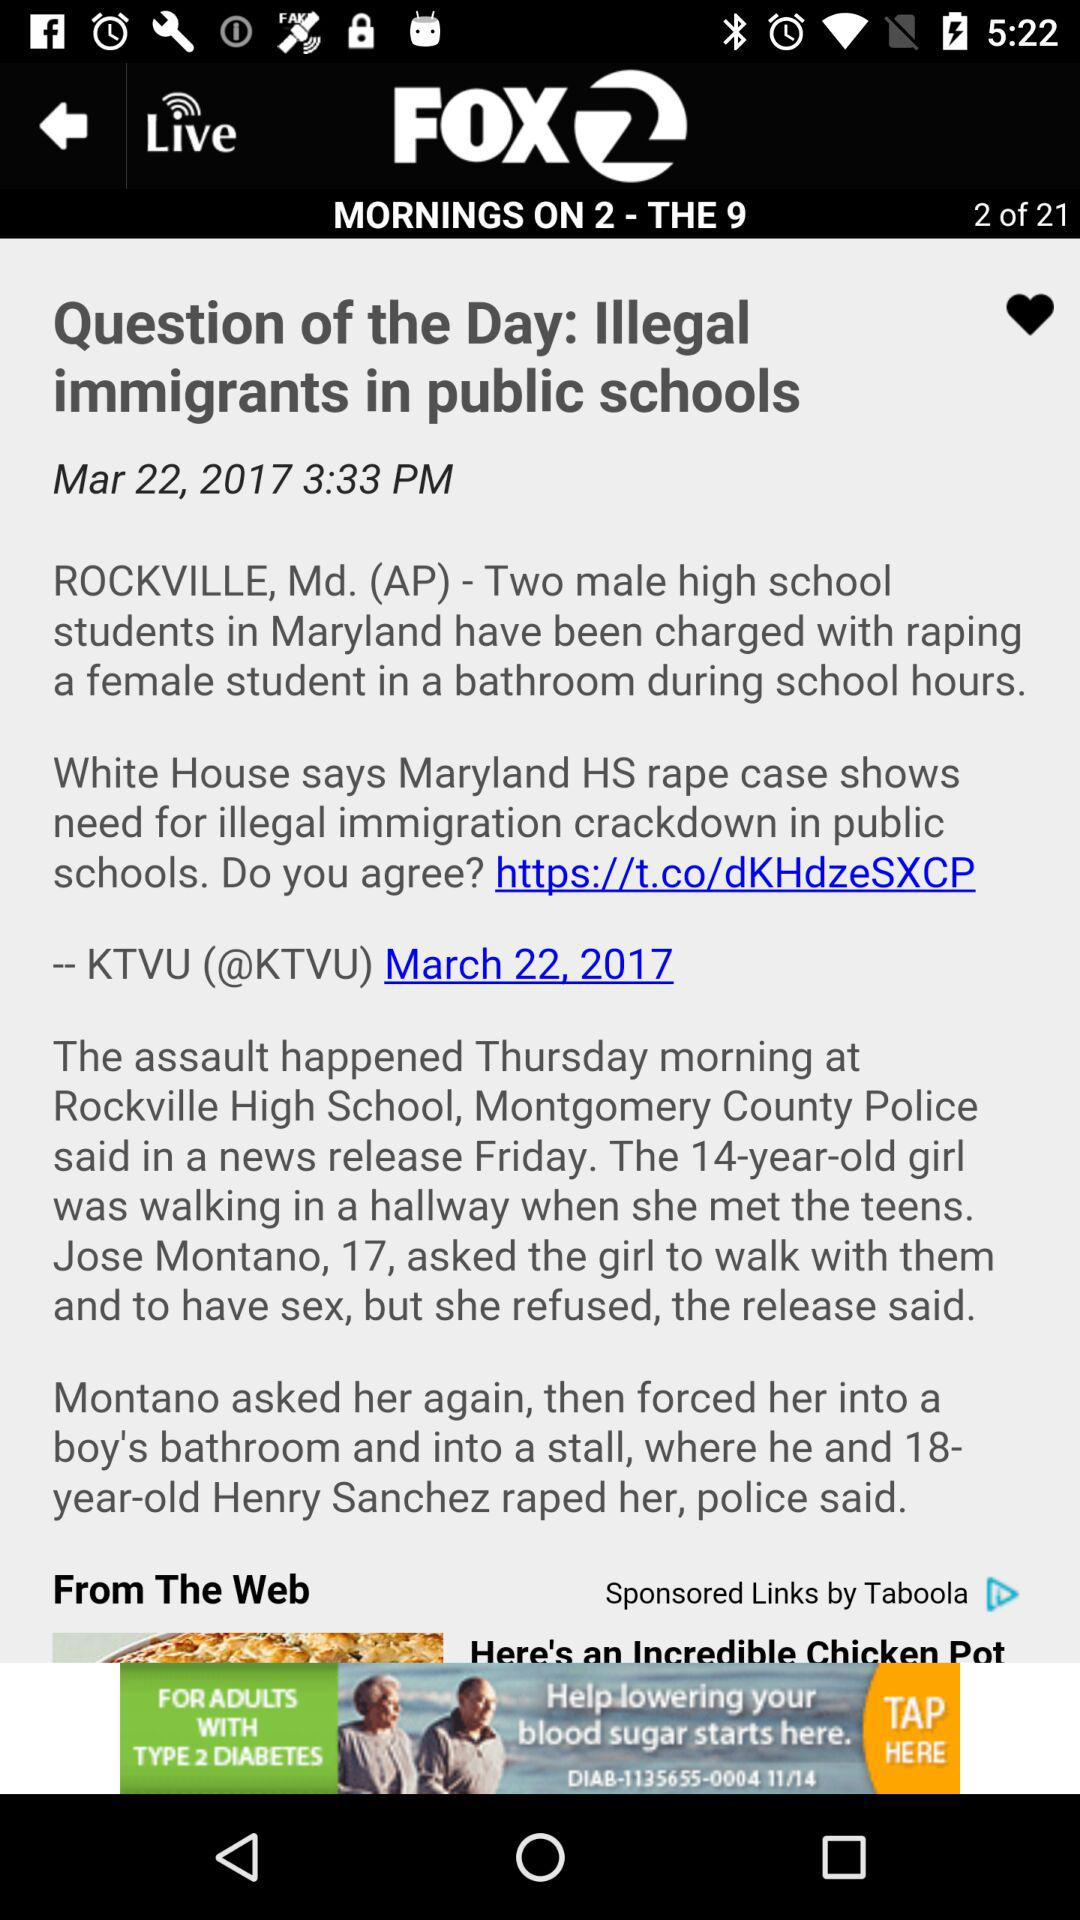What is the publication date of the news? The publication date of the news is March 22, 2017. 